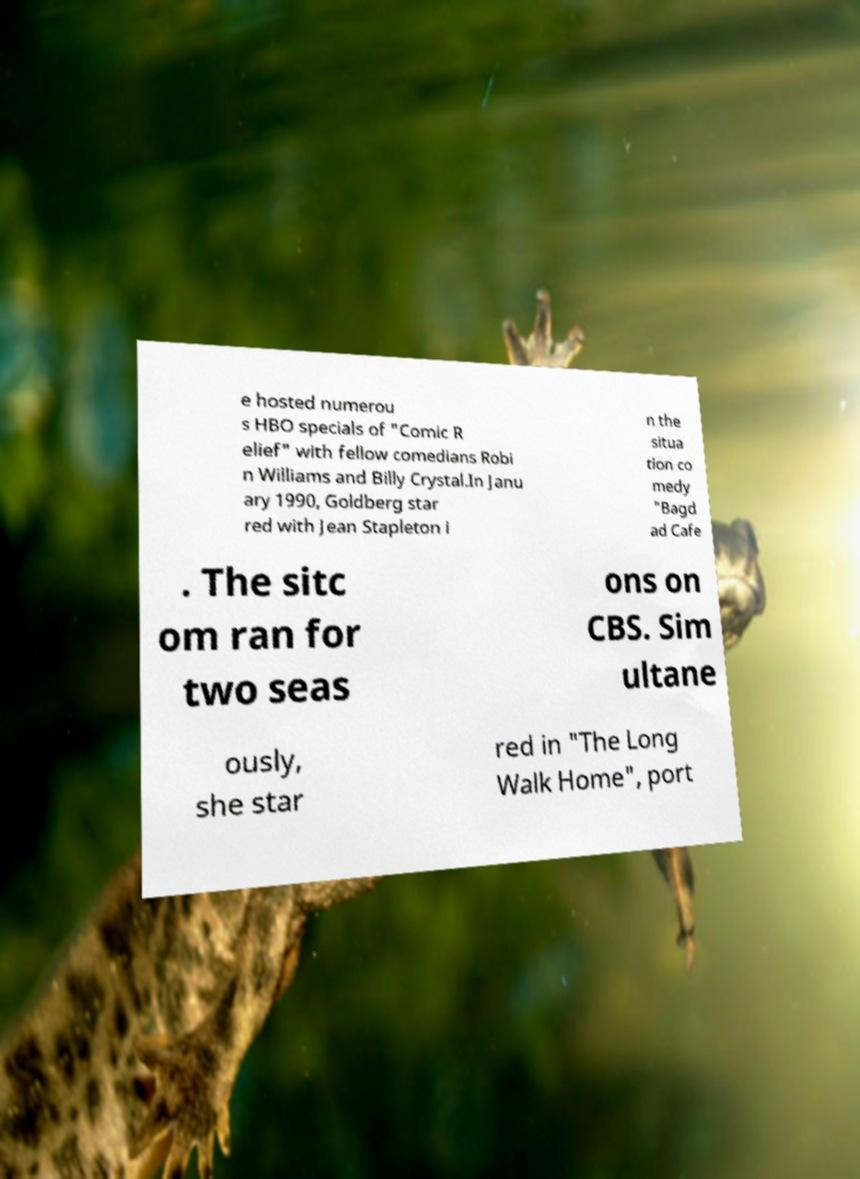Please read and relay the text visible in this image. What does it say? e hosted numerou s HBO specials of "Comic R elief" with fellow comedians Robi n Williams and Billy Crystal.In Janu ary 1990, Goldberg star red with Jean Stapleton i n the situa tion co medy "Bagd ad Cafe . The sitc om ran for two seas ons on CBS. Sim ultane ously, she star red in "The Long Walk Home", port 